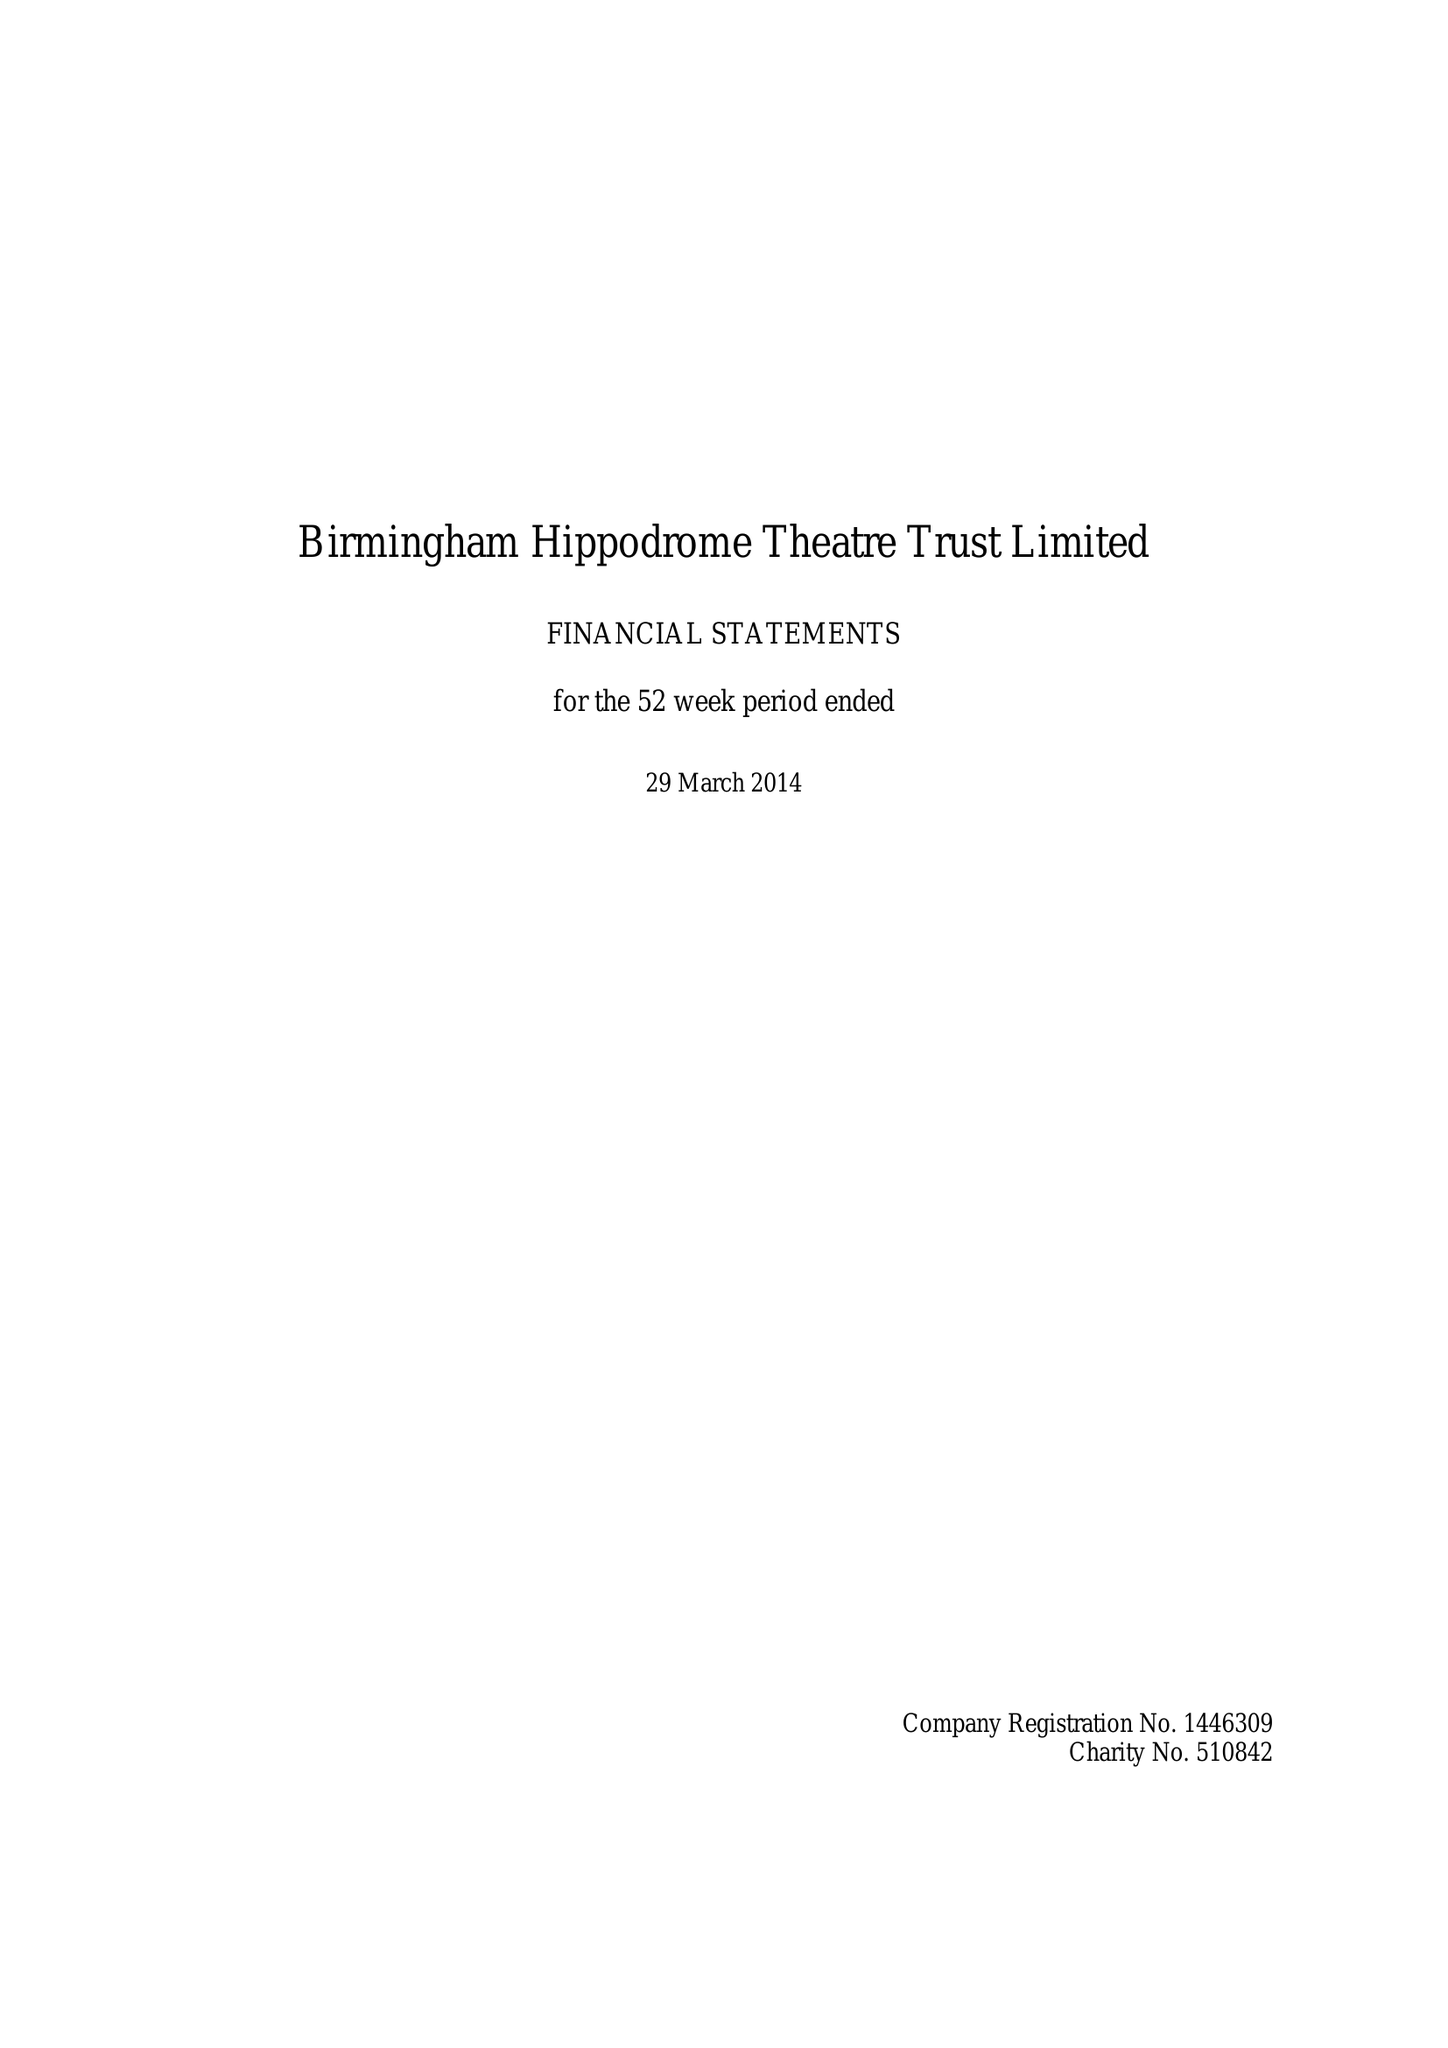What is the value for the spending_annually_in_british_pounds?
Answer the question using a single word or phrase. 30131000.00 